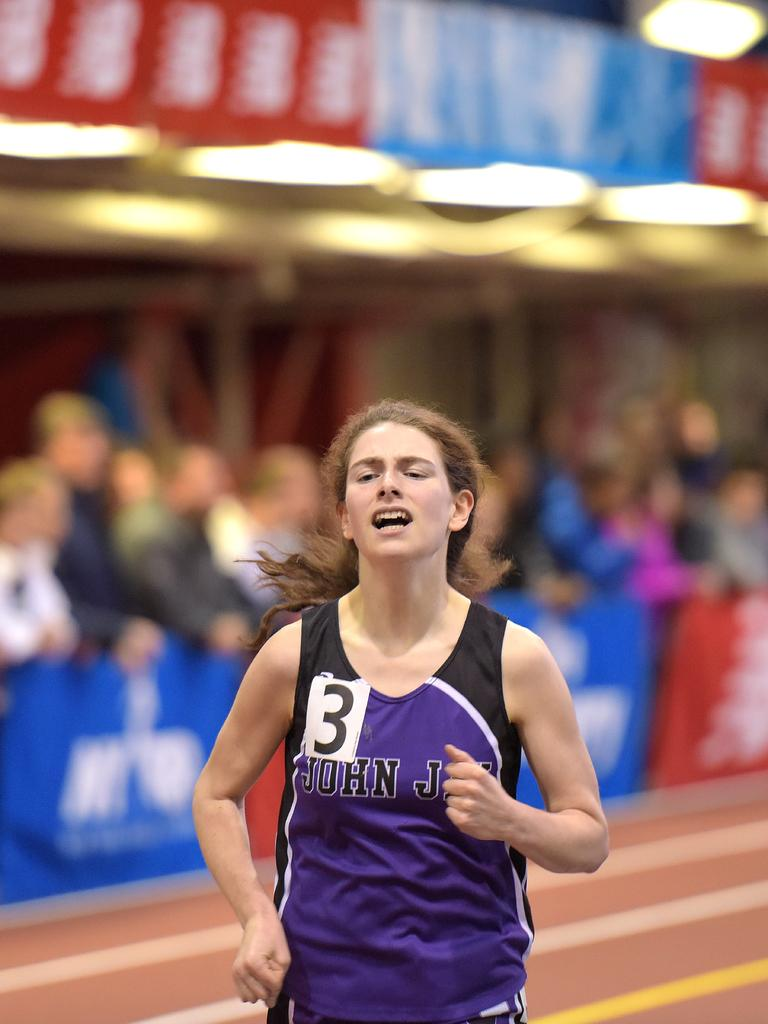<image>
Offer a succinct explanation of the picture presented. A female runner in a purple vest which has the number 3 on it. 